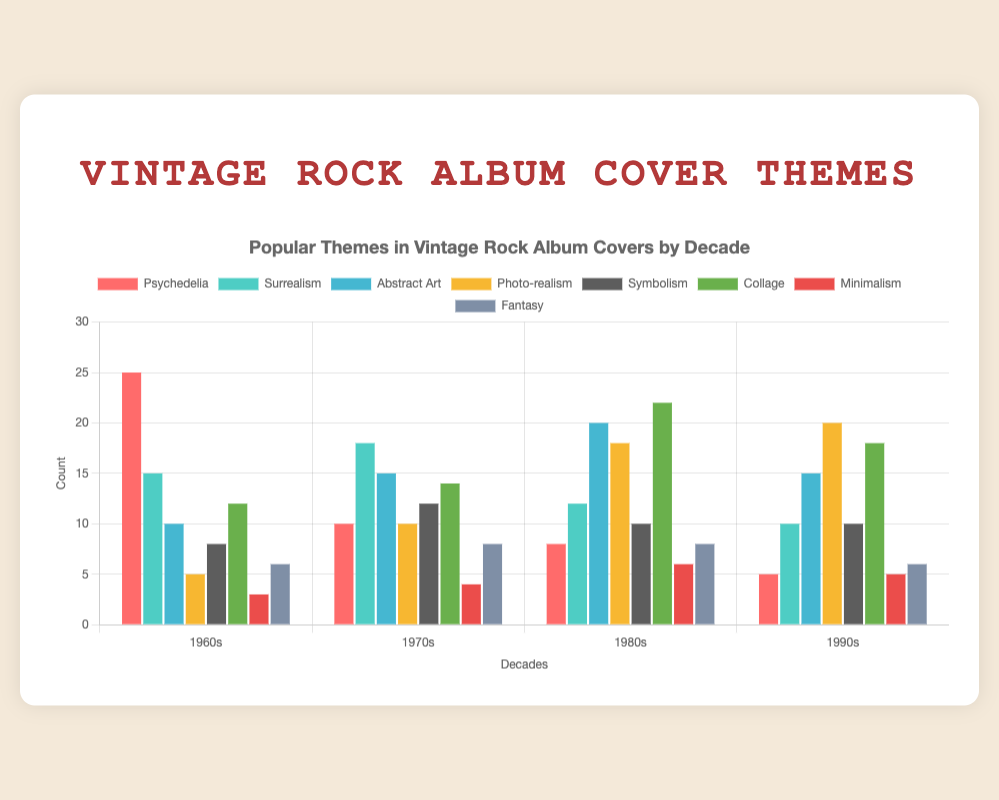Which theme was most popular in the 1960s? To determine the most popular theme in the 1960s, observe the highest bar for that decade. The "Psychedelia" theme has the highest count at 25.
Answer: Psychedelia Which decade had the highest count of Photo-realism covers? Compare the heights of the Photo-realism bars across all decades. The 1990s have the highest count at 20.
Answer: 1990s Which theme saw a consistent increase in count from the 1960s to the 1990s? Check each theme's count across the decades to identify a consistent increase. None of the themes shows a consistent increase across all decades.
Answer: None What is the difference in count for 'Abstract Art' between the 1970s and 1980s? For Abstract Art, the count is 15 in the 1970s and 20 in the 1980s. Subtract the 1970s count from the 1980s count: 20 - 15 = 5.
Answer: 5 Which two themes had the same count in the 1980s? Look at the bars for the 1980s and find themes with matching heights. 'Psychedelia' and 'Fantasy' both have a count of 8.
Answer: Psychedelia and Fantasy What is the total count of 'Collage' themes from all decades? Add the counts of 'Collage' from all decades: 12 (1960s) + 14 (1970s) + 22 (1980s) + 18 (1990s) = 66.
Answer: 66 Which decade had the lowest count of Minimalism covers? Compare the Minimalism counts across all decades. The 1960s had the lowest count with 3.
Answer: 1960s What is the average count of 'Surrealism' themes across the four decades? Add the Surrealism counts from all decades then divide by the number of decades: (15 + 18 + 12 + 10) / 4 = 13.75.
Answer: 13.75 Which theme was least popular in the 1980s? Identify the shortest bar for the 1980s. 'Minimalism' has the lowest count at 6.
Answer: Minimalism 